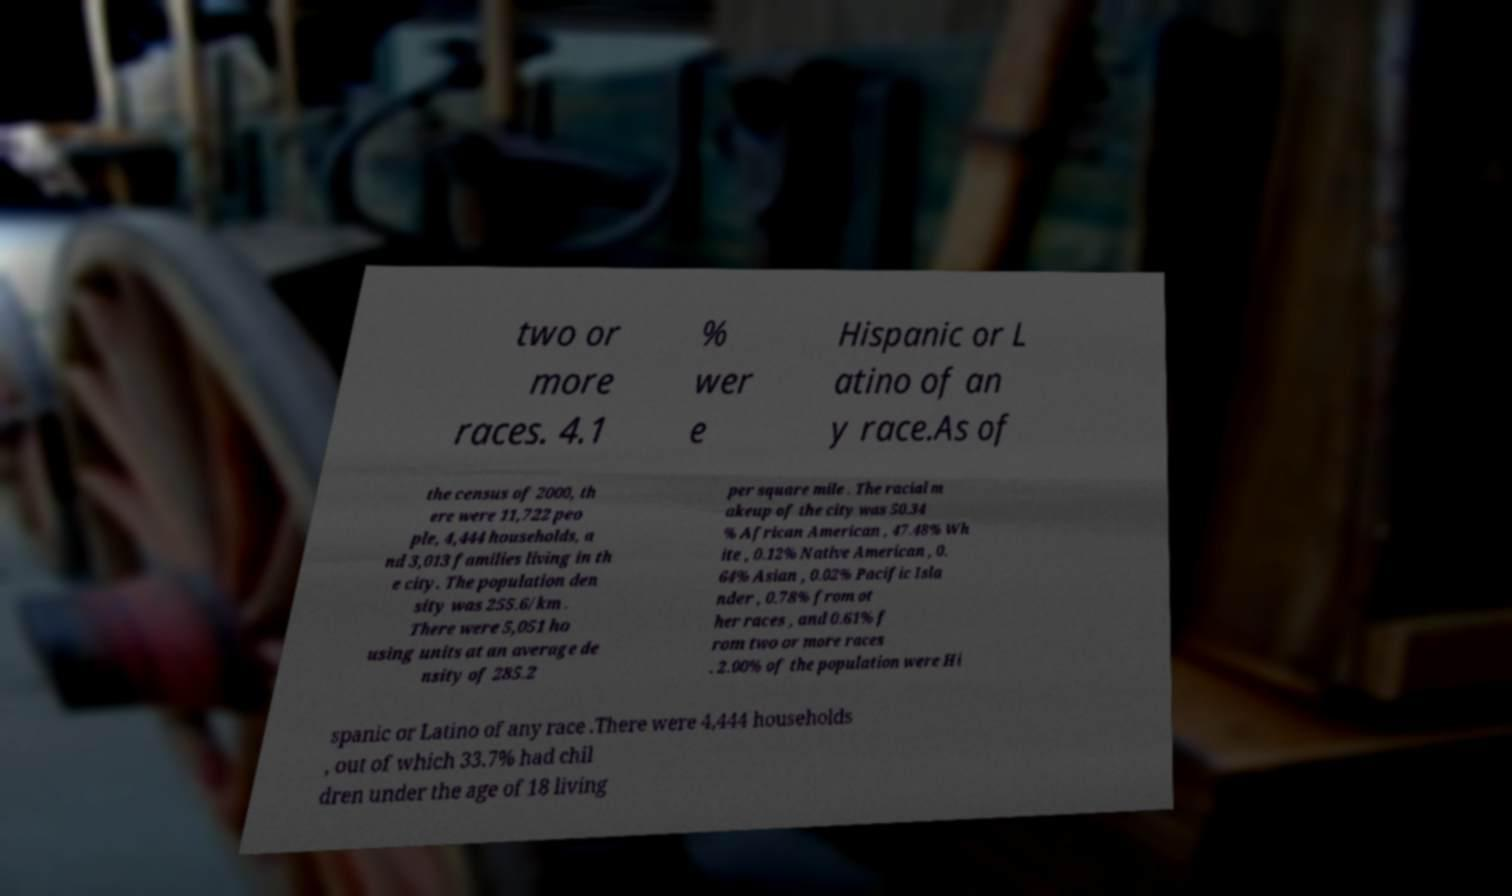For documentation purposes, I need the text within this image transcribed. Could you provide that? two or more races. 4.1 % wer e Hispanic or L atino of an y race.As of the census of 2000, th ere were 11,722 peo ple, 4,444 households, a nd 3,013 families living in th e city. The population den sity was 255.6/km . There were 5,051 ho using units at an average de nsity of 285.2 per square mile . The racial m akeup of the city was 50.34 % African American , 47.48% Wh ite , 0.12% Native American , 0. 64% Asian , 0.02% Pacific Isla nder , 0.78% from ot her races , and 0.61% f rom two or more races . 2.00% of the population were Hi spanic or Latino of any race .There were 4,444 households , out of which 33.7% had chil dren under the age of 18 living 